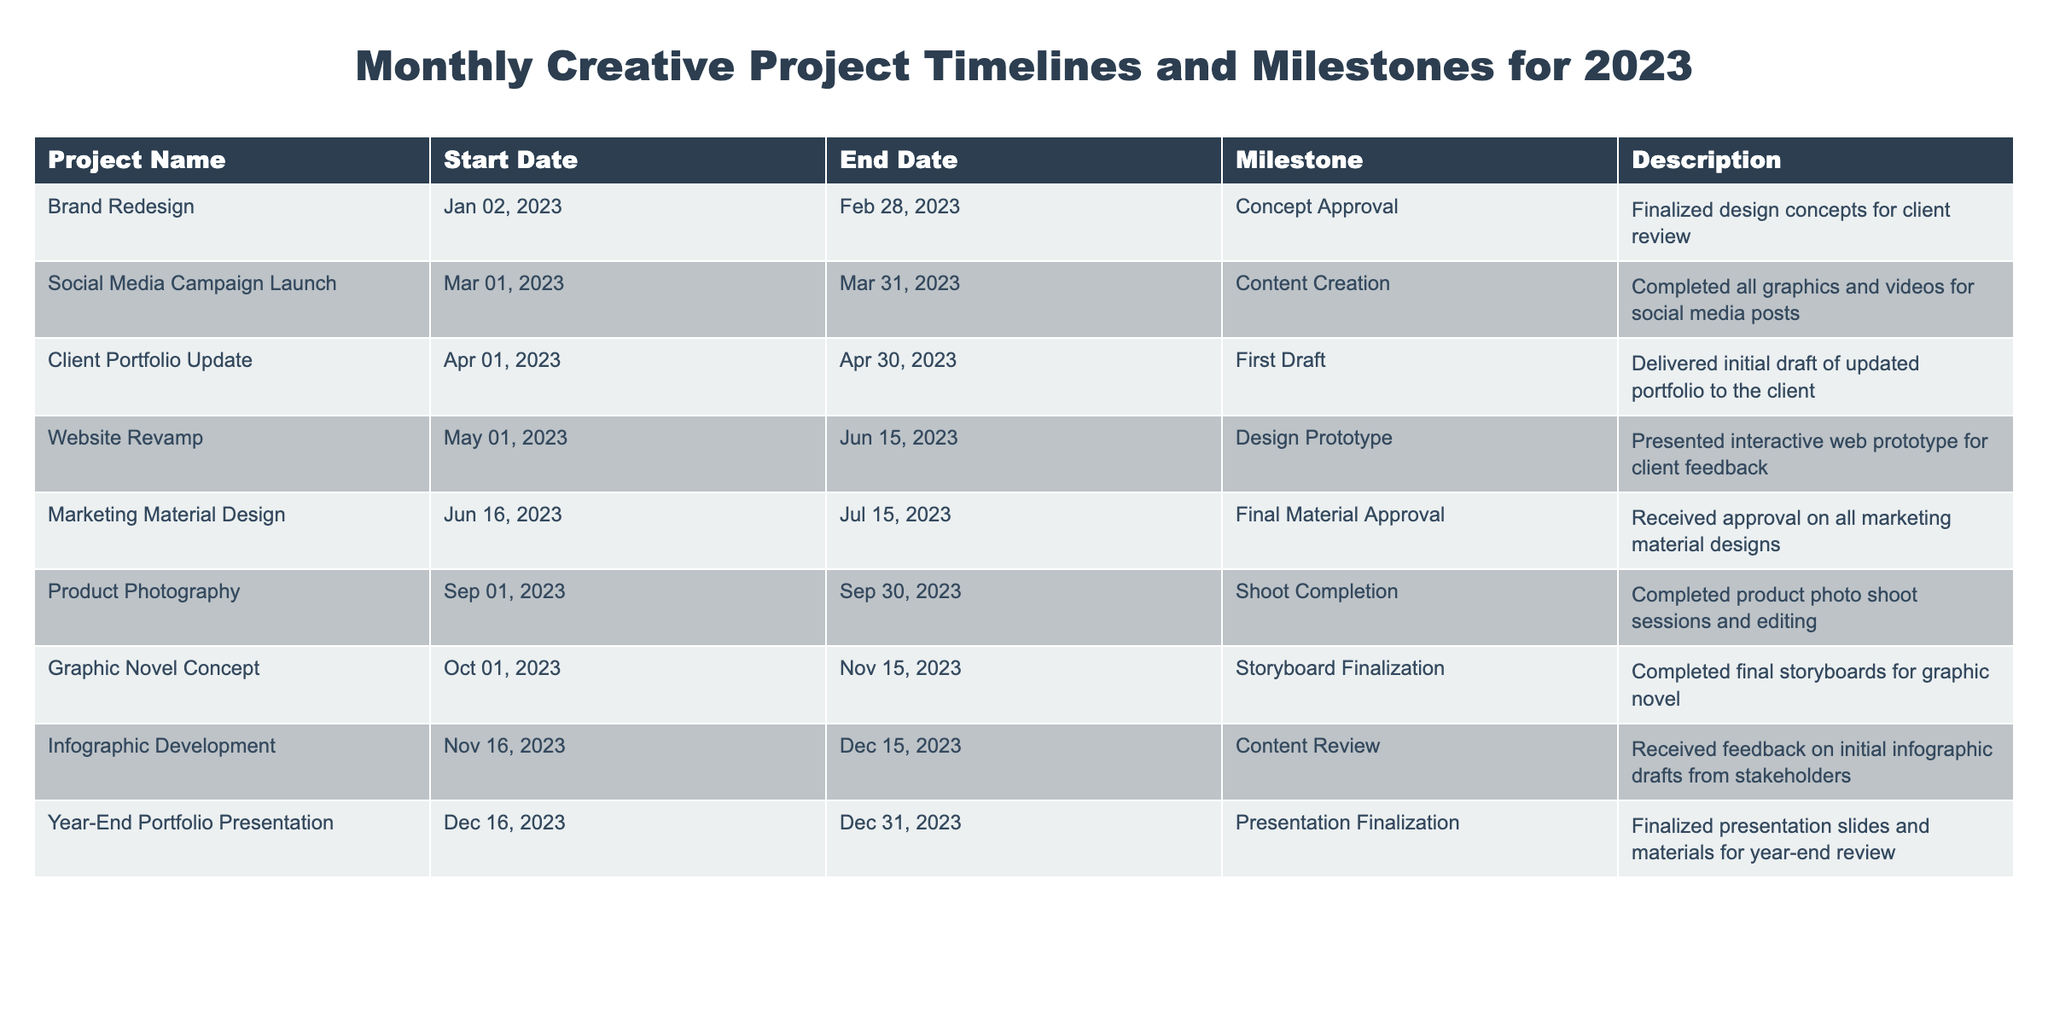What is the duration of the Brand Redesign project? The Brand Redesign project starts on January 2, 2023, and ends on February 28, 2023. The duration can be calculated by counting the days between these two dates, which is 58 days.
Answer: 58 days Which project has the latest end date? The project with the latest end date is the Year-End Portfolio Presentation, which ends on December 31, 2023.
Answer: Year-End Portfolio Presentation Did the Product Photography project have a milestone? Yes, the Product Photography project has a milestone called "Shoot Completion."
Answer: Yes How many projects were completed in the third quarter (July to September) of 2023? Looking at the table, the only project that falls within the third quarter is the Product Photography project, which started in September. Since there’s only one project during this time frame, the count is 1.
Answer: 1 What is the average duration of the projects listed in the table? To find the average duration, we need to calculate the duration of each project: Brand Redesign (58 days), Social Media Campaign Launch (31 days), Client Portfolio Update (30 days), Website Revamp (46 days), Marketing Material Design (30 days), Product Photography (30 days), Graphic Novel Concept (46 days), Infographic Development (30 days), Year-End Portfolio Presentation (16 days). Summing these durations gives 367 days, and with 9 projects, the average duration is 367 / 9 = 40.78 days.
Answer: 40.78 days Is the Milestone for the graphic novel project the earliest milestone listed? No, the Graphic Novel Concept project's milestone (Storyboard Finalization) is on October 1, 2023. The earliest milestone is the Concept Approval for the Brand Redesign project on January 2, 2023.
Answer: No Which project involves client feedback and what is its milestone? The Website Revamp project involves client feedback. Its milestone is the "Design Prototype."
Answer: Website Revamp, Design Prototype How many projects were focused on content creation before August 2023? The projects that focused on content creation before August 2023 are Brand Redesign, Social Media Campaign Launch, and Client Portfolio Update, totaling 3 projects.
Answer: 3 What is the total number of days for the Client Portfolio Update and the Year-End Portfolio Presentation projects combined? The Client Portfolio Update has a duration of 30 days, and the Year-End Portfolio Presentation lasts for 16 days. Adding these together gives 30 + 16 = 46 days.
Answer: 46 days Which project comes right after the Marketing Material Design? The next project after Marketing Material Design is the Product Photography project.
Answer: Product Photography 